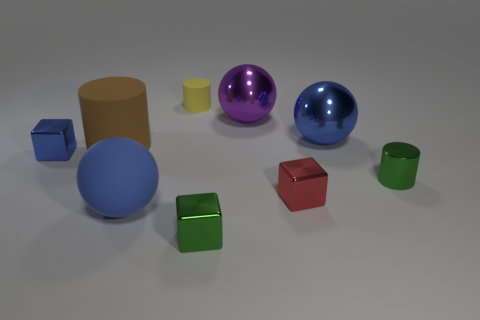The tiny metallic object that is the same color as the rubber ball is what shape?
Keep it short and to the point. Cube. What number of rubber things are yellow things or green blocks?
Your answer should be very brief. 1. How many blocks are both to the right of the small yellow cylinder and left of the purple shiny object?
Provide a succinct answer. 1. Are there any other things that are the same shape as the big purple shiny object?
Your response must be concise. Yes. How many other objects are the same size as the brown rubber cylinder?
Your response must be concise. 3. There is a blue ball that is in front of the tiny red metallic object; is it the same size as the matte thing behind the brown matte cylinder?
Your answer should be very brief. No. How many things are either blue metallic objects or blue things that are behind the brown cylinder?
Make the answer very short. 2. There is a blue thing that is in front of the tiny red object; what is its size?
Offer a terse response. Large. Is the number of small yellow rubber objects that are on the left side of the small blue metal block less than the number of brown cylinders that are on the right side of the small green cylinder?
Provide a succinct answer. No. What material is the blue object that is both on the left side of the green cube and behind the metallic cylinder?
Ensure brevity in your answer.  Metal. 